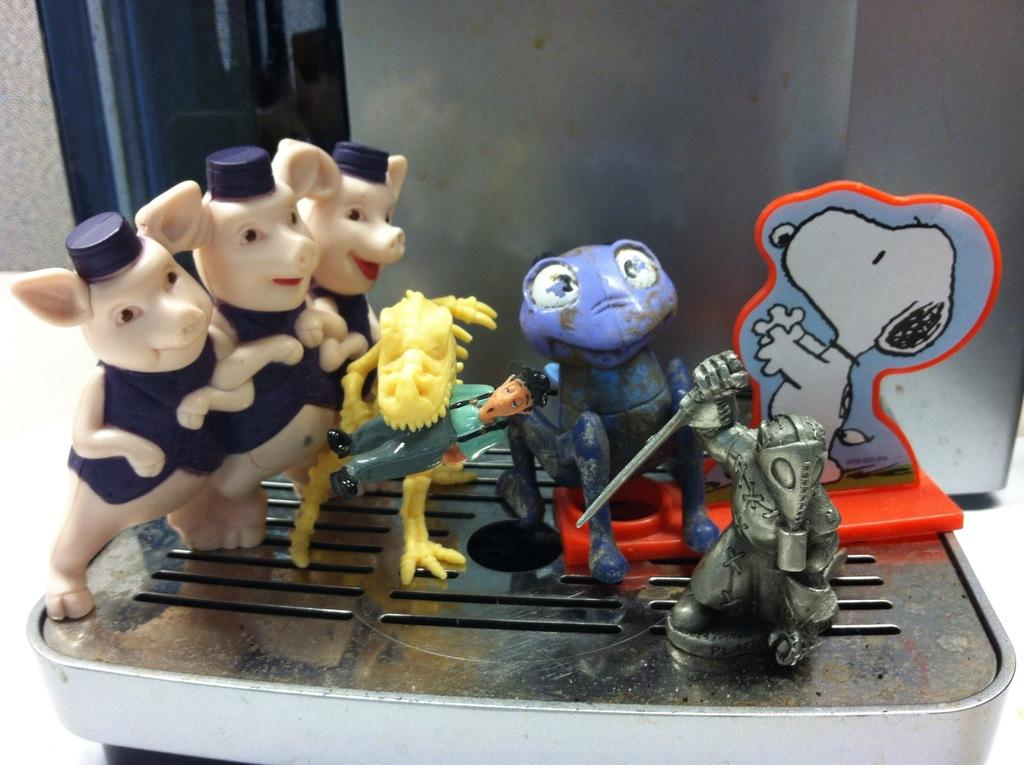What objects are on the machine in the image? There are toys on the machine in the image. Where is the machine located? The machine is on a table in the image. What can be seen through the window in the image? The window is on a wall, but the conversation does not provide information about what can be seen through it. Can you describe the window in the image? The window is on a wall in the image. What is the chance of the toys being granted a wish by the whip in the image? There is no whip or mention of wishes in the image; it features toys on a machine and a window on a wall. 